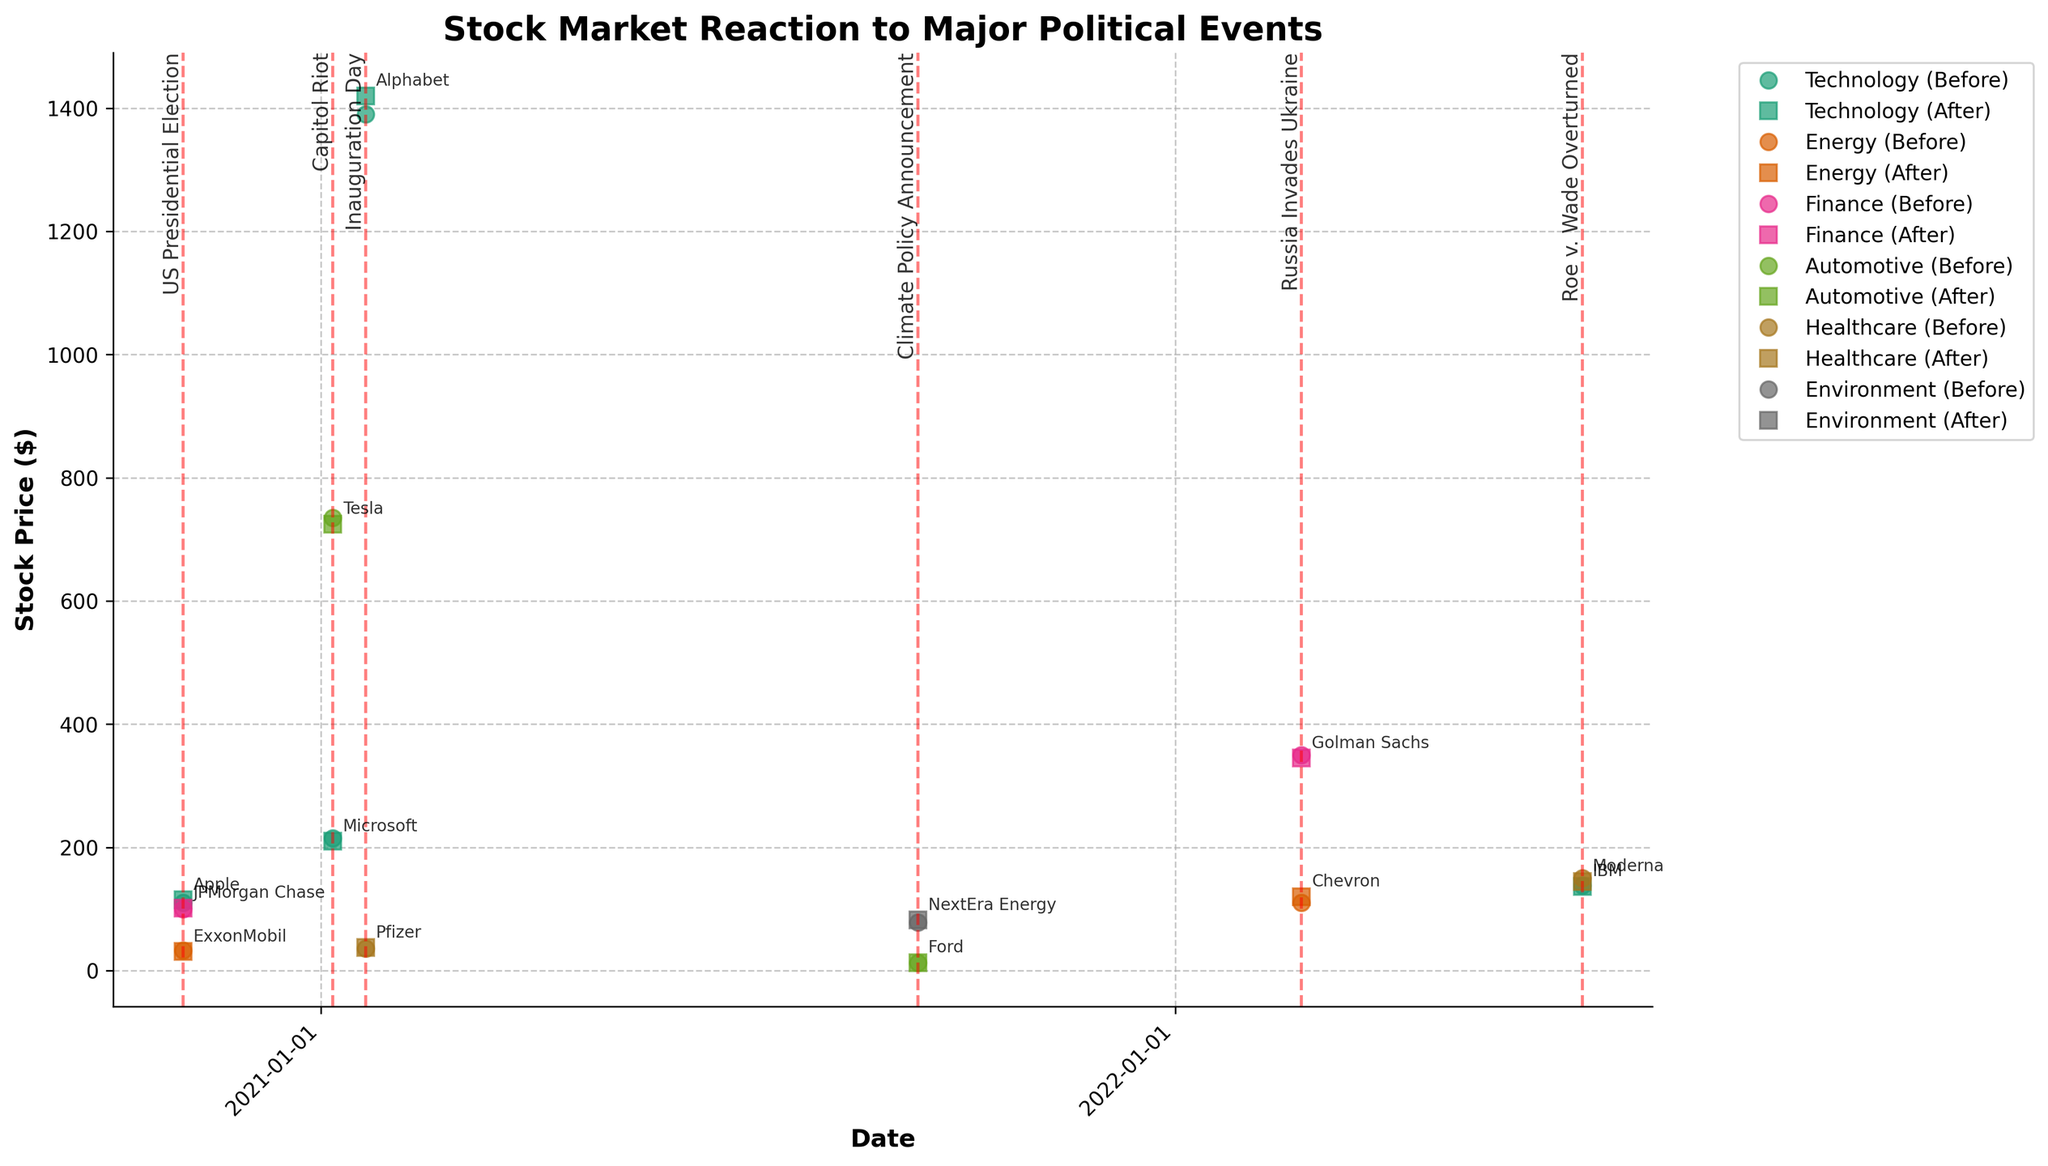Which industry saw an increase in stock price after the US Presidential Election? To determine the industry that saw an increase, we look at the "Stock_Price_After" values for the US Presidential Election event. Technology (Apple) increased from 110.00 to 115.00, and Finance (JPMorgan Chase) increased from 100.00 to 101.50.
Answer: Technology and Finance Which company's stock price decreased the most after a major political event? To find the company with the largest decrease in stock price, subtract the "Stock_Price_After" from "Stock_Price_Before" for each company and identify the largest negative difference. Microsoft during the Capitol Riot went from 215.00 to 210.00 (-5.00).
Answer: Microsoft How did the automotive industry react to the Capitol Riot? Reference the "Stock_Price_Before" and "Stock_Price_After" for the Automotive industry during the Capitol Riot. Tesla's stock dropped from 735.00 to 725.00.
Answer: Tesla’s stock price decreased by 10.00 On Inauguration Day, which company had the highest stock price after the event? Identify the stock prices after Inauguration Day and compare them. Alphabet had the highest closing price of 1420.00.
Answer: Alphabet How did Chevron's stock price react to Russia Invading Ukraine? Check "Stock_Price_Before" and "Stock_Price_After" for Chevron on the specified date. Chevron’s stock increased from 110.00 to 120.00.
Answer: Chevron’s stock price increased by 10.00 What was the stock price trend for the healthcare industry related to the Roe v. Wade Overturned event? Identify the "Stock_Price_Before" and "Stock_Price_After" for Moderna (Healthcare) during Roe v. Wade Overturned. Moderna's stock price decreased from 150.00 to 145.00.
Answer: Decreased by 5.00 Comparing JPMorgan Chase on the US Presidential Election and Goldman Sachs during Russia Invading Ukraine, which company had a higher stock price after the respective event? Look at the "Stock_Price_After" for JPMorgan Chase and Goldman Sachs. JPMorgan Chase had a stock price of 101.50, and Goldman Sachs had 345.00.
Answer: Goldman Sachs Which industry benefited the most relative to stock price increase on Climate Policy Announcement? Identify the "Stock_Price_Before" and "Stock_Price_After" for industries affected by the Climate Policy Announcement. NextEra Energy's stock increased from 78.00 to 82.00, a change of 4.00, and Ford’s stock increased from 12.50 to 13.00, a change of 0.50. NextEra Energy had the highest relative increase.
Answer: Environment (NextEra Energy) Did any industry consistently see a decrease in stock prices after events? To answer this, we analyze all instances where "Stock_Price_Before" is greater than "Stock_Price_After" for each industry. Energy (ExxonMobil) fell from 33.00 to 31.00 during the US Presidential Election, and Finance (Golman Sachs) fell from 350.00 to 345.00 during Russia Invades Ukraine. However, no single industry consistently decreased across all events.
Answer: No industry consistently saw a decrease Which political event seemed to have the most varied impact across different industries? Determine the variances in stock price changes for each event across affected industries. For the US Presidential Election, we observe both increases and decreases for different industries: Technology (Apple) +5.00, Energy (ExxonMobil) -2.00, Finance (JPMorgan Chase) +1.50.
Answer: US Presidential Election 